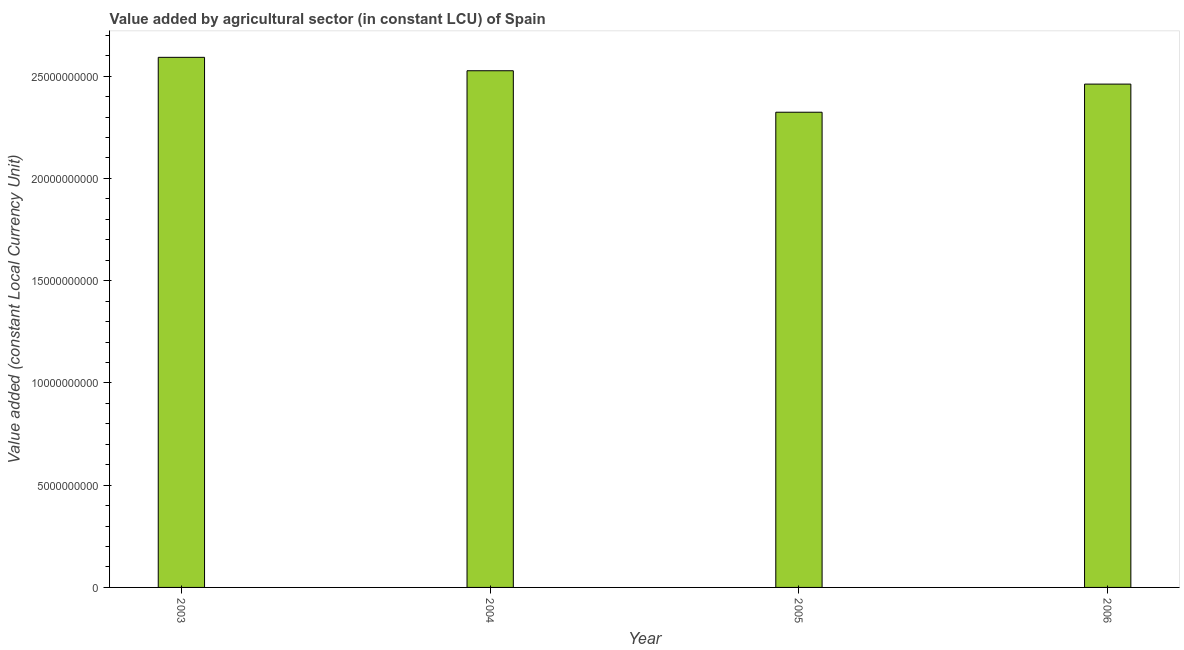Does the graph contain any zero values?
Provide a short and direct response. No. What is the title of the graph?
Offer a terse response. Value added by agricultural sector (in constant LCU) of Spain. What is the label or title of the Y-axis?
Keep it short and to the point. Value added (constant Local Currency Unit). What is the value added by agriculture sector in 2003?
Your response must be concise. 2.59e+1. Across all years, what is the maximum value added by agriculture sector?
Your answer should be compact. 2.59e+1. Across all years, what is the minimum value added by agriculture sector?
Provide a succinct answer. 2.32e+1. In which year was the value added by agriculture sector maximum?
Your response must be concise. 2003. In which year was the value added by agriculture sector minimum?
Your answer should be compact. 2005. What is the sum of the value added by agriculture sector?
Provide a short and direct response. 9.90e+1. What is the difference between the value added by agriculture sector in 2003 and 2005?
Keep it short and to the point. 2.68e+09. What is the average value added by agriculture sector per year?
Provide a short and direct response. 2.48e+1. What is the median value added by agriculture sector?
Provide a short and direct response. 2.49e+1. Do a majority of the years between 2006 and 2005 (inclusive) have value added by agriculture sector greater than 2000000000 LCU?
Provide a short and direct response. No. What is the ratio of the value added by agriculture sector in 2003 to that in 2005?
Provide a succinct answer. 1.12. What is the difference between the highest and the second highest value added by agriculture sector?
Provide a succinct answer. 6.56e+08. Is the sum of the value added by agriculture sector in 2003 and 2004 greater than the maximum value added by agriculture sector across all years?
Offer a terse response. Yes. What is the difference between the highest and the lowest value added by agriculture sector?
Give a very brief answer. 2.68e+09. In how many years, is the value added by agriculture sector greater than the average value added by agriculture sector taken over all years?
Make the answer very short. 2. How many bars are there?
Provide a short and direct response. 4. Are all the bars in the graph horizontal?
Make the answer very short. No. How many years are there in the graph?
Ensure brevity in your answer.  4. What is the difference between two consecutive major ticks on the Y-axis?
Your answer should be very brief. 5.00e+09. Are the values on the major ticks of Y-axis written in scientific E-notation?
Your answer should be compact. No. What is the Value added (constant Local Currency Unit) in 2003?
Keep it short and to the point. 2.59e+1. What is the Value added (constant Local Currency Unit) in 2004?
Provide a short and direct response. 2.53e+1. What is the Value added (constant Local Currency Unit) in 2005?
Give a very brief answer. 2.32e+1. What is the Value added (constant Local Currency Unit) of 2006?
Provide a succinct answer. 2.46e+1. What is the difference between the Value added (constant Local Currency Unit) in 2003 and 2004?
Offer a terse response. 6.56e+08. What is the difference between the Value added (constant Local Currency Unit) in 2003 and 2005?
Your response must be concise. 2.68e+09. What is the difference between the Value added (constant Local Currency Unit) in 2003 and 2006?
Your answer should be compact. 1.31e+09. What is the difference between the Value added (constant Local Currency Unit) in 2004 and 2005?
Your answer should be compact. 2.03e+09. What is the difference between the Value added (constant Local Currency Unit) in 2004 and 2006?
Keep it short and to the point. 6.53e+08. What is the difference between the Value added (constant Local Currency Unit) in 2005 and 2006?
Your answer should be very brief. -1.38e+09. What is the ratio of the Value added (constant Local Currency Unit) in 2003 to that in 2005?
Make the answer very short. 1.12. What is the ratio of the Value added (constant Local Currency Unit) in 2003 to that in 2006?
Your response must be concise. 1.05. What is the ratio of the Value added (constant Local Currency Unit) in 2004 to that in 2005?
Provide a succinct answer. 1.09. What is the ratio of the Value added (constant Local Currency Unit) in 2005 to that in 2006?
Provide a succinct answer. 0.94. 